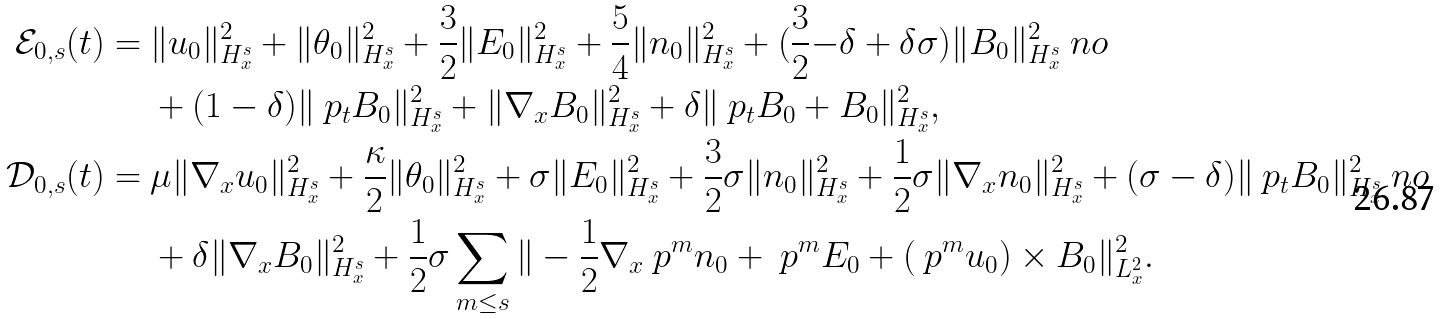Convert formula to latex. <formula><loc_0><loc_0><loc_500><loc_500>\mathcal { E } _ { 0 , s } ( t ) = \ & \| u _ { 0 } \| ^ { 2 } _ { H ^ { s } _ { x } } + \| \theta _ { 0 } \| ^ { 2 } _ { H ^ { s } _ { x } } + \frac { 3 } { 2 } \| E _ { 0 } \| ^ { 2 } _ { H ^ { s } _ { x } } + \frac { 5 } { 4 } \| n _ { 0 } \| ^ { 2 } _ { H ^ { s } _ { x } } + ( \frac { 3 } { 2 } { - \delta + \delta \sigma } ) \| B _ { 0 } \| ^ { 2 } _ { H ^ { s } _ { x } } \ n o \\ & + ( 1 - \delta ) \| \ p _ { t } B _ { 0 } \| ^ { 2 } _ { H ^ { s } _ { x } } + \| \nabla _ { x } B _ { 0 } \| ^ { 2 } _ { H ^ { s } _ { x } } + \delta \| \ p _ { t } B _ { 0 } + B _ { 0 } \| ^ { 2 } _ { H ^ { s } _ { x } } , \\ \mathcal { D } _ { 0 , s } ( t ) = \ & \mu \| \nabla _ { x } u _ { 0 } \| ^ { 2 } _ { H ^ { s } _ { x } } + \frac { \kappa } { 2 } \| \theta _ { 0 } \| ^ { 2 } _ { H ^ { s } _ { x } } + \sigma \| E _ { 0 } \| ^ { 2 } _ { H ^ { s } _ { x } } + \frac { 3 } { 2 } \sigma \| n _ { 0 } \| ^ { 2 } _ { H ^ { s } _ { x } } + \frac { 1 } { 2 } \sigma \| \nabla _ { x } n _ { 0 } \| ^ { 2 } _ { H ^ { s } _ { x } } + ( \sigma - \delta ) \| \ p _ { t } B _ { 0 } \| ^ { 2 } _ { H ^ { s } _ { x } } \ n o \\ & + \delta \| \nabla _ { x } B _ { 0 } \| ^ { 2 } _ { H ^ { s } _ { x } } + \frac { 1 } { 2 } \sigma \sum _ { m \leq s } \| - \frac { 1 } { 2 } \nabla _ { x } \ p ^ { m } n _ { 0 } + \ p ^ { m } E _ { 0 } + ( \ p ^ { m } u _ { 0 } ) \times B _ { 0 } \| ^ { 2 } _ { L ^ { 2 } _ { x } } .</formula> 